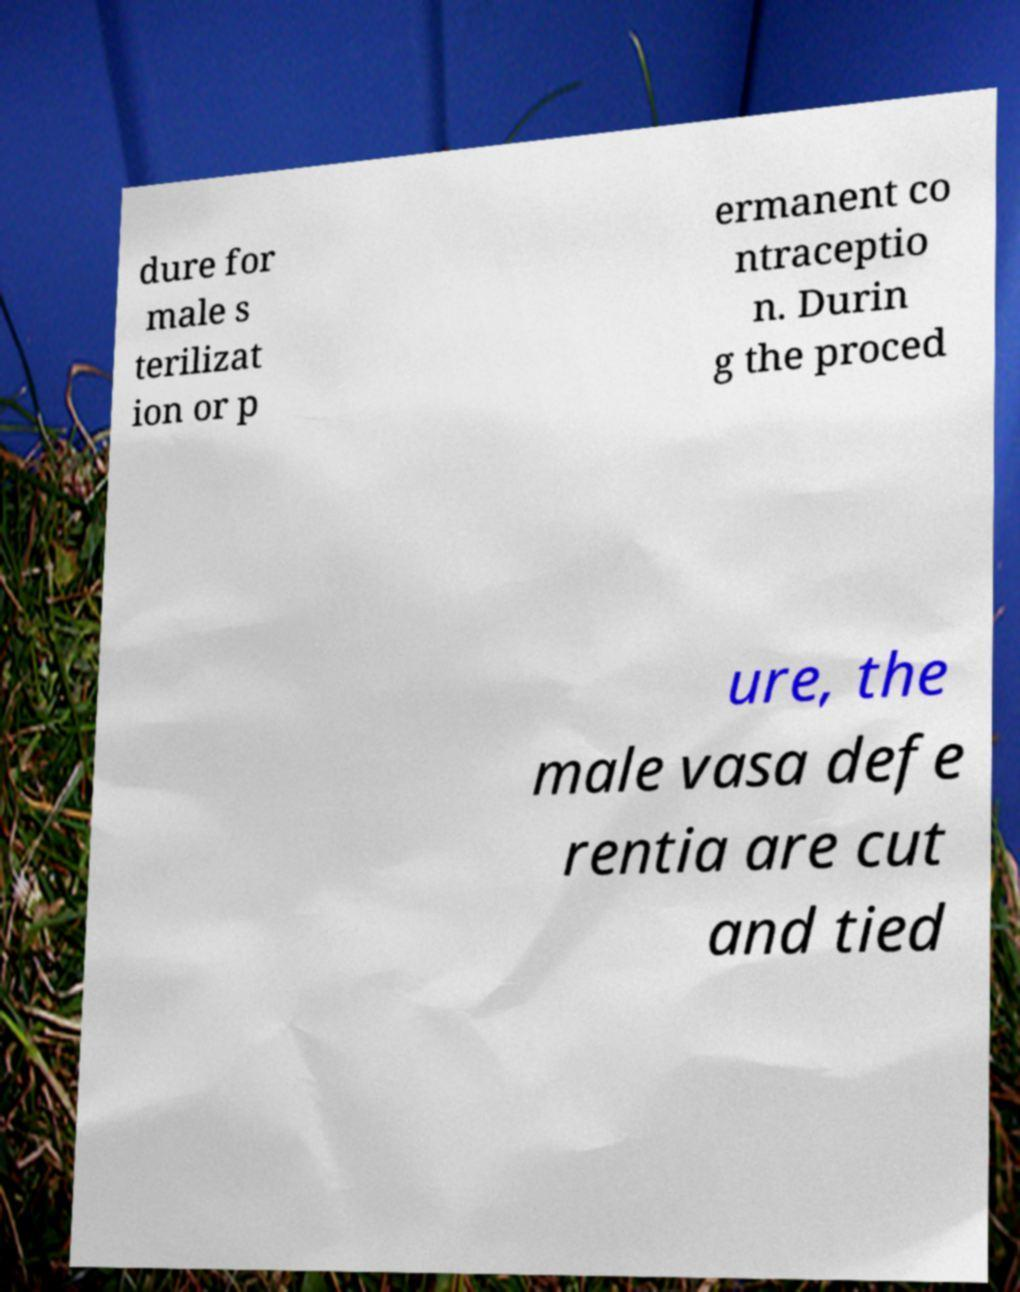Could you assist in decoding the text presented in this image and type it out clearly? dure for male s terilizat ion or p ermanent co ntraceptio n. Durin g the proced ure, the male vasa defe rentia are cut and tied 